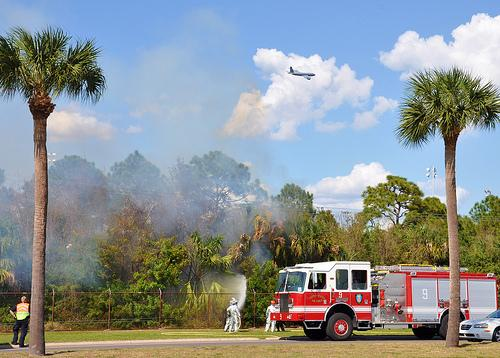Give a concise description of what is taking place in the image and any notable features. Firefighters are putting out a tree fire, with relevant elements such as a firetruck, white car, and a plane flying above. In a single sentence, describe the setting and activity happening in the photo. The photo captures a firefighting operation in a forested area, with a parked firetruck and white car, and a plane flying overhead. Describe the key components of the image and the main action being taken. Firefighters are spraying water on a burning tree, while a firetruck and a white car are parked nearby, and a plane flies in the sky. Craft a brief summary of the visual elements contained in the image. The image features firefighters combating a tree fire, a firetruck and white car, a plane in the sky, and smoke rising from the trees. Detail the main activity happening in the photo and notable visual elements in the scene. The image shows firefighters actively fighting a tree fire, with a parked firetruck and white car nearby and a plane flying in the sky. Mention the primary focus of the image and any actions that may be taking place. Firefighters are fighting a tree fire with a hose, as smoke rises from the nearby forest and a plane flies in the sky above. Write a concise statement about what the focal point of the image is and any significant details. The focus is on firefighters extinguishing a tree fire, with supplementary details like a plane, firetruck, and white car present in the scene. Write a brief description of the scene captured in the image. The image shows a scene of firefighters working to put out a tree fire, with other noteworthy elements such as a plane in the sky and a white car. Using as few words as possible, describe the primary action and subjects in the image. Firefighters tackling tree fire, plane in sky, firetruck, and white car nearby. Create a brief narrative about what is happening in the picture. In the middle of a smoky forest, brave firefighters are working to extinguish a tree fire, while a firetruck, white car, and plane provide supporting elements in the scene. Can you find a cat sitting near the fence at X:95 Y:288? The statement given about these coordinates is "the fence is red," and there is no mention of a cat, making this question misleading. Does the plane flying at X:286 Y:64 look like a helicopter?  The image contains multiple captions about a plane and not a helicopter, making this interrogation misleading. There is a man wearing a purple shirt standing at X:215 Y:295. The correct information is that "the firemen are standing" at those coordinates, and no mention of a purple shirt was made. Can you see a black car parked at X:457 Y:302?  The input clearly mentions "the car is white"; hence, mentioning a black car would be misleading. Observe the snowy landscape in the image and describe it. There are no sections or objects that indicate a snowy landscape in any of the given captions and information, making this declarative sentence misleading. Is the tree at the coordinates X:239 Y:227 blue and healthy? The original information mentioned that "the tree is burnt" which implies the tree is not in a healthy state and no color was mentioned. Look for a large green bush located at X:42 Y:140. The original information stated "the forest is smoking" which indicates a forest fire; therefore, a large green bush would be misleading. Is there a group of children playing at X:222 Y:297?  The mention of "some men in white" does not imply any presence of children, misleading the interrogative sentence. Please describe the ocean waves at the position X:65 Y:150. The coordinates mention a "section of some many trees" and not an ocean, making this a misleading instruction. Are there any mountains visible at the coordinates X:224 Y:55? The specific coordinates mention "a cloud in the sky"; no mountains were mentioned in any caption. 